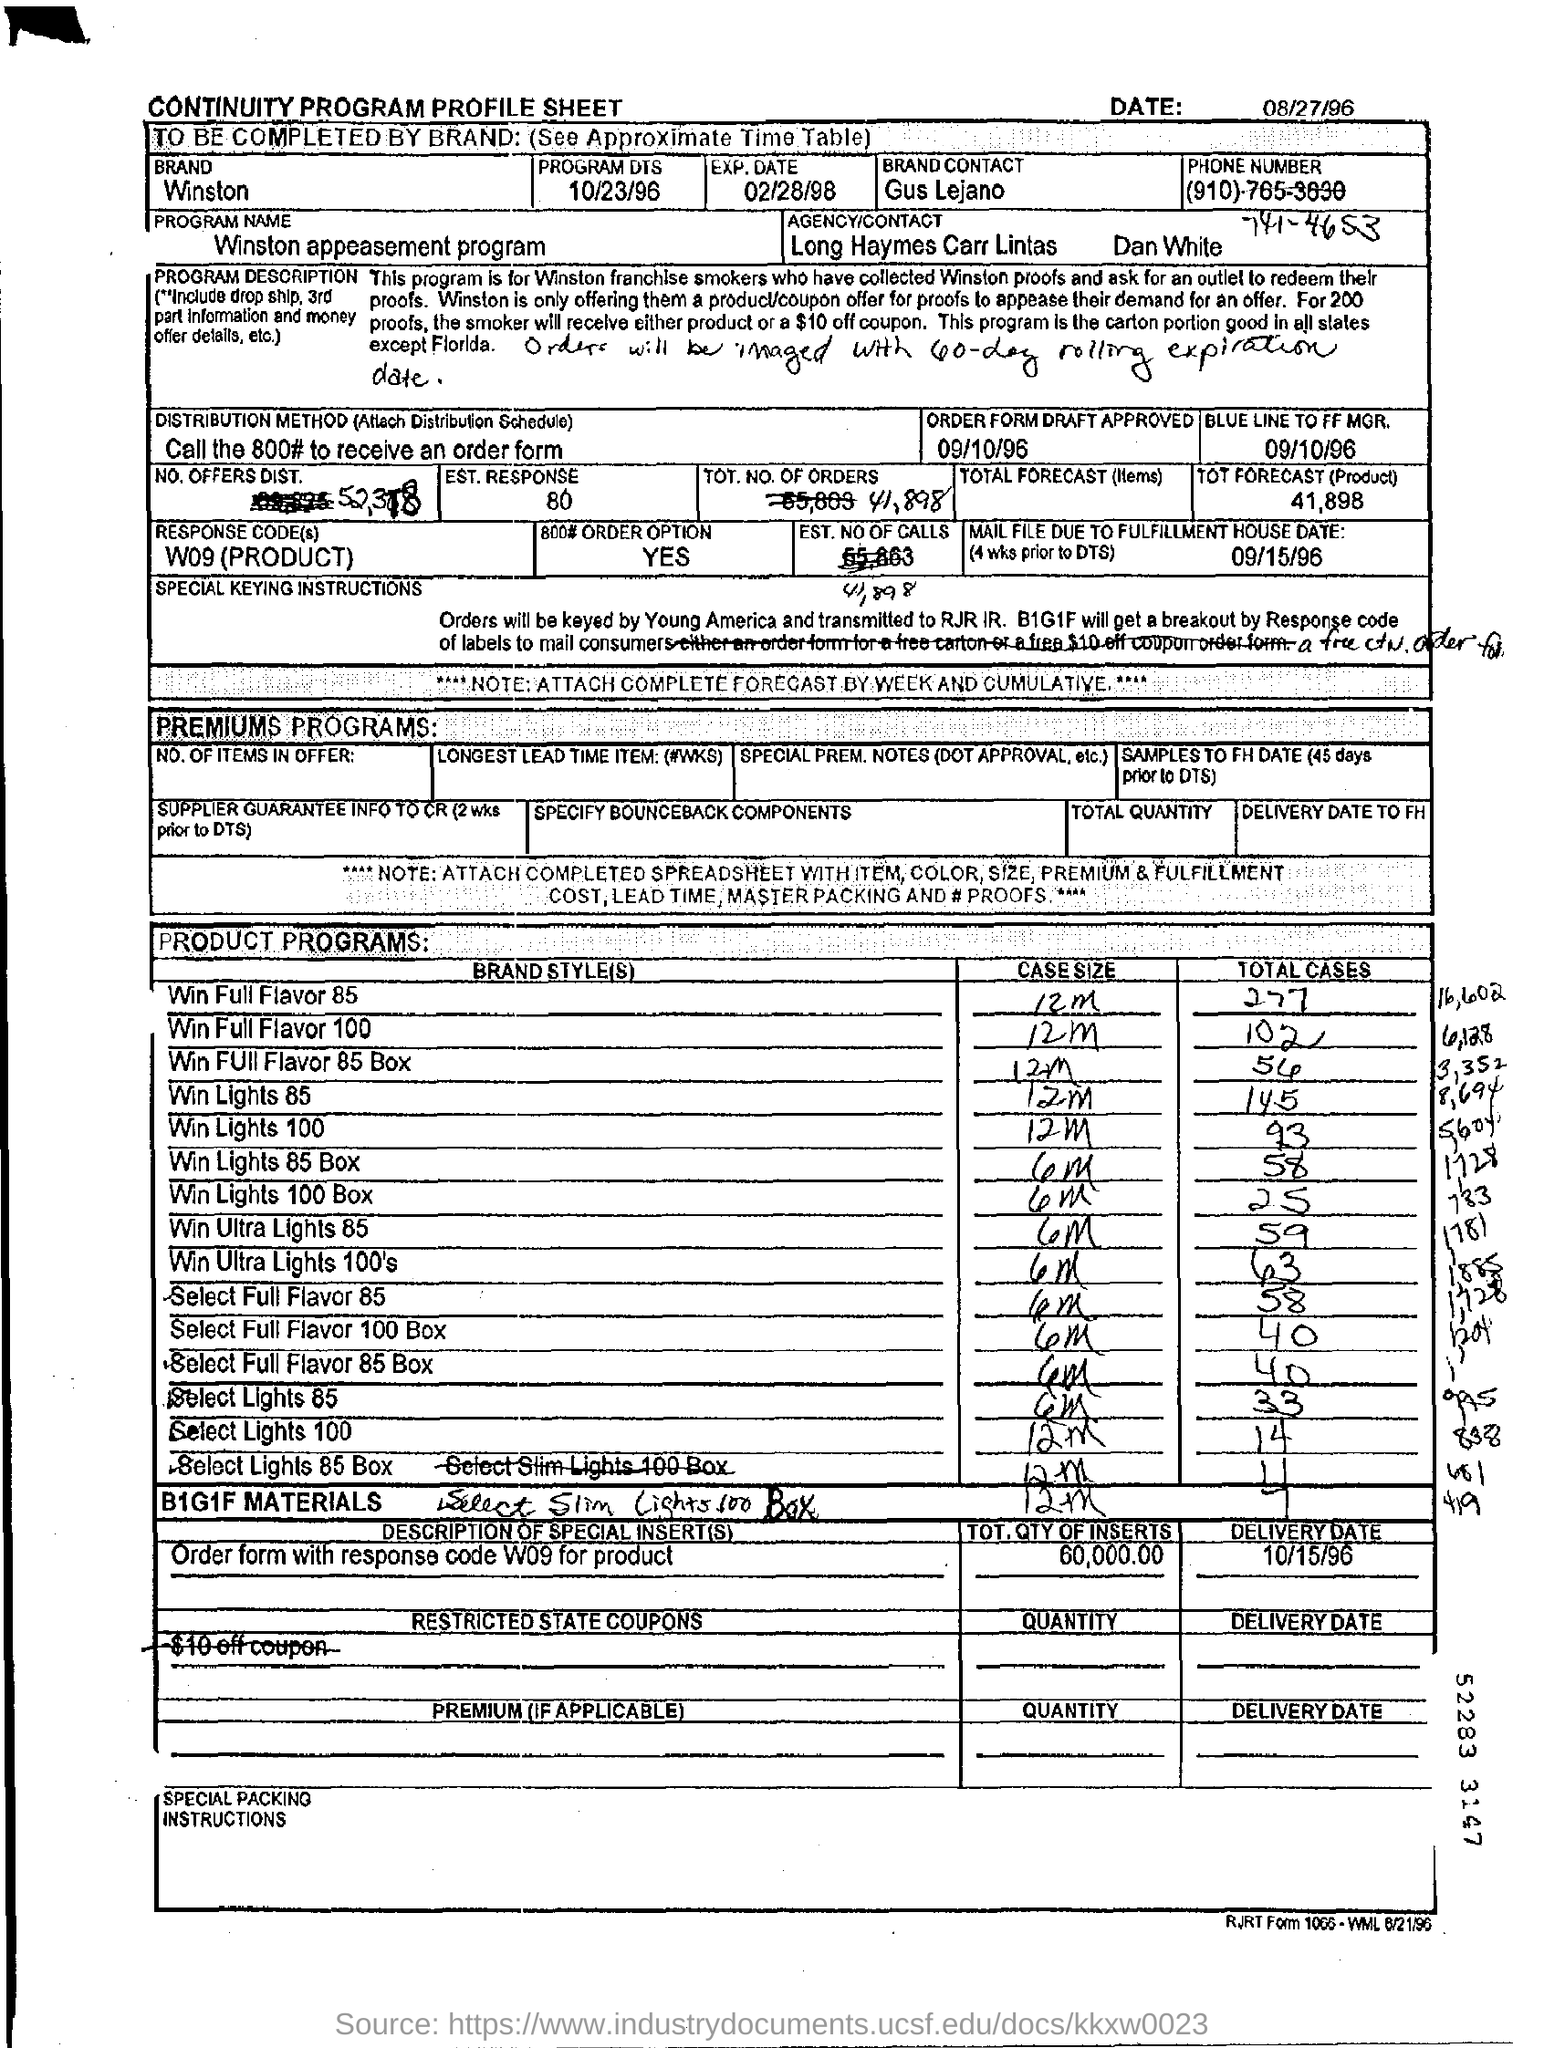What is the date mentioned in the top of the document ?
Offer a very short reply. 08/27/96. What is written in the Brand Field ?
Your answer should be very brief. Winston. What is mentioned in the Response Code Field ?
Make the answer very short. W09(PRODUCT). What is the Case Size of Win Full Flavor 100 ?
Offer a terse response. 12m. What is written in the EST.RESPONSE Field ?
Offer a terse response. 80. What is the Program Name ?
Offer a terse response. Winston appeasement program. 